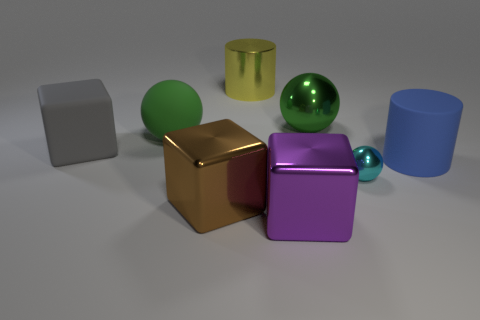Subtract all metallic blocks. How many blocks are left? 1 Subtract all yellow cylinders. How many cylinders are left? 1 Subtract all cubes. How many objects are left? 5 Add 2 tiny gray shiny things. How many objects exist? 10 Subtract 3 cubes. How many cubes are left? 0 Subtract 1 blue cylinders. How many objects are left? 7 Subtract all blue cylinders. Subtract all red cubes. How many cylinders are left? 1 Subtract all green spheres. How many cyan cubes are left? 0 Subtract all green shiny balls. Subtract all brown blocks. How many objects are left? 6 Add 8 big gray rubber cubes. How many big gray rubber cubes are left? 9 